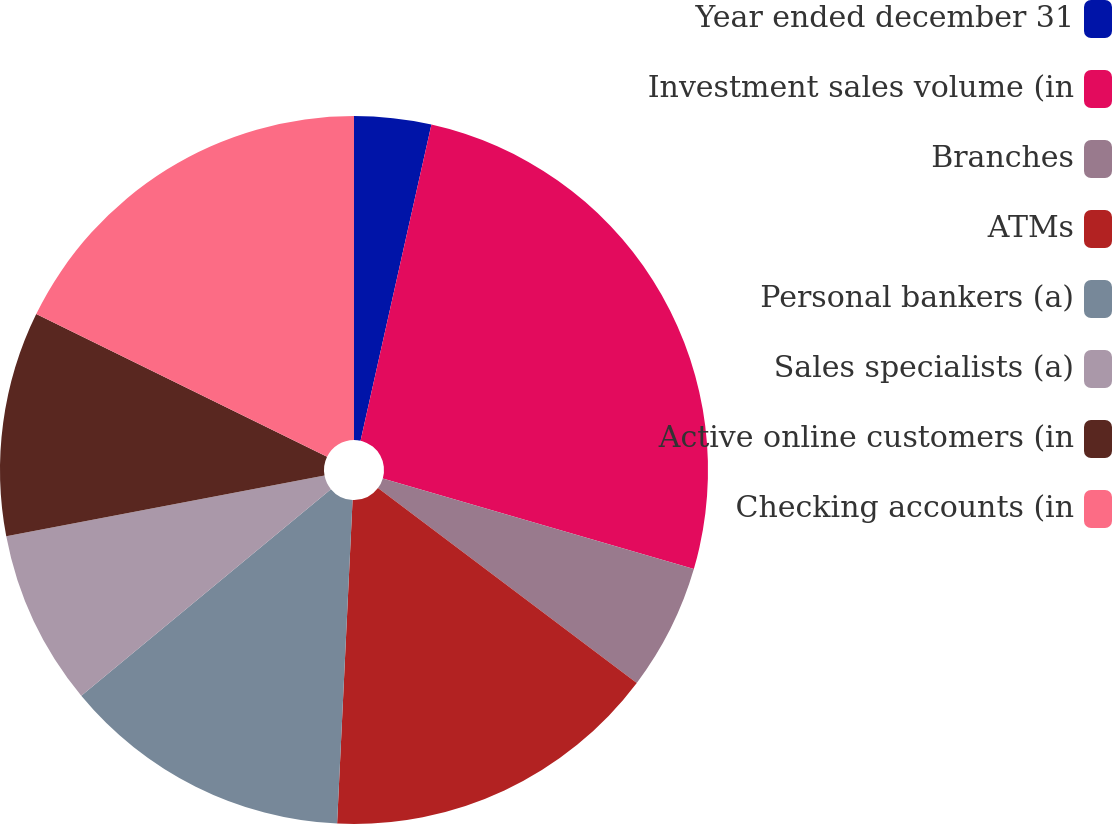Convert chart to OTSL. <chart><loc_0><loc_0><loc_500><loc_500><pie_chart><fcel>Year ended december 31<fcel>Investment sales volume (in<fcel>Branches<fcel>ATMs<fcel>Personal bankers (a)<fcel>Sales specialists (a)<fcel>Active online customers (in<fcel>Checking accounts (in<nl><fcel>3.51%<fcel>26.01%<fcel>5.76%<fcel>15.49%<fcel>13.24%<fcel>8.01%<fcel>10.26%<fcel>17.74%<nl></chart> 